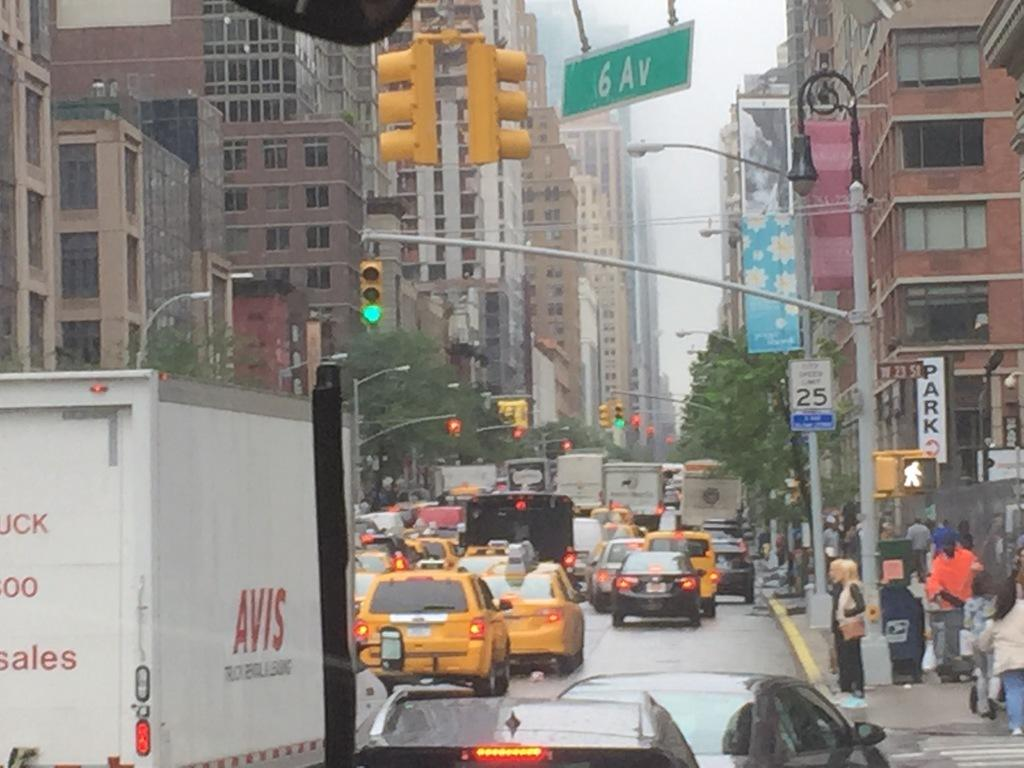<image>
Describe the image concisely. Traffic is backed up at the intersection of West 23rd and 6th Ave. 